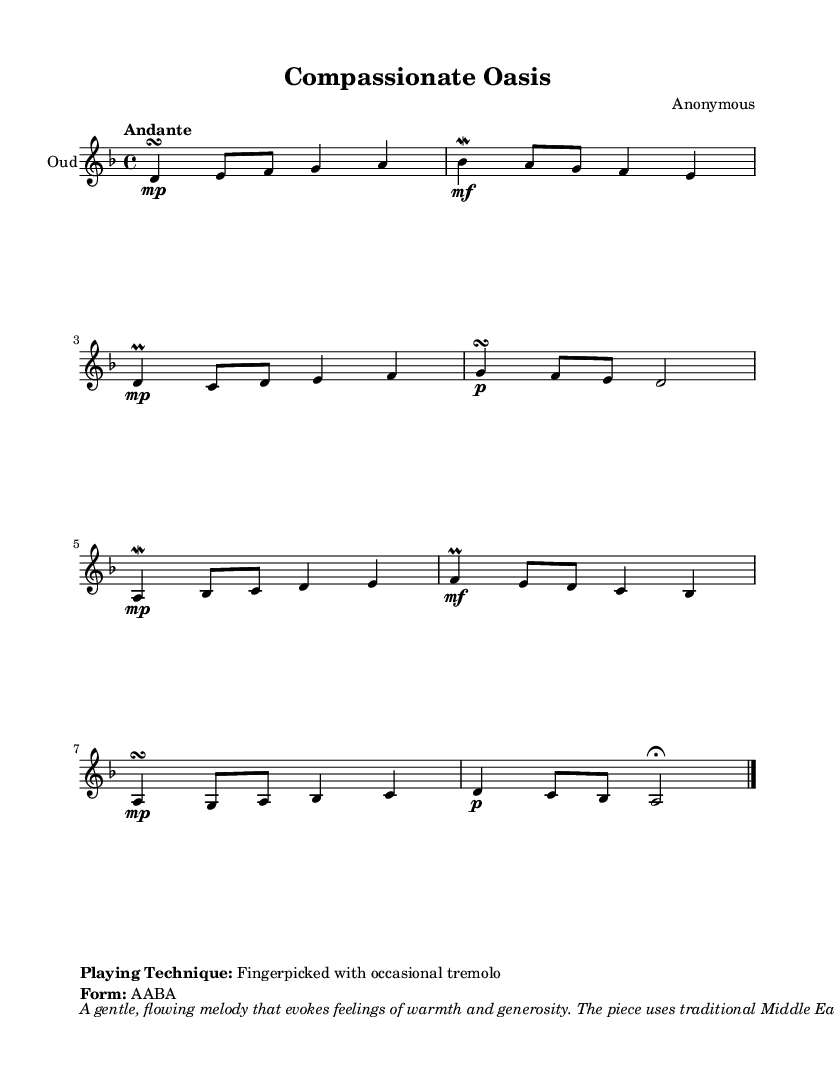What is the key signature of this music? The key signature is D minor, which is indicated by one flat in the signature (B flat).
Answer: D minor What is the time signature of the piece? The time signature shown at the beginning is 4/4, indicating four beats per measure with a quarter note receiving one beat.
Answer: 4/4 What is the tempo marking for the piece? The tempo marking of "Andante" suggests a moderate pace, typically ranging from 76 to 108 beats per minute.
Answer: Andante How many measures does the melody contain? The provided melody comprises a total of eight measures, as counted from the vertical lines separating each measure.
Answer: Eight What is the form of the piece? The form of this composition is indicated as "AABA," meaning it consists of two similar sections (A), followed by a contrasting section (B), and then returning to the first section (A).
Answer: AABA What playing technique is specified for the oud in this score? The playing technique described is "Fingerpicked with occasional tremolo," which indicates how the oud should be played to convey its expressive qualities.
Answer: Fingerpicked with occasional tremolo What themes does this piece evoke according to the markup? The piece evokes feelings of warmth and generosity, reflecting its themes of compassion in the composition.
Answer: Warmth and generosity 